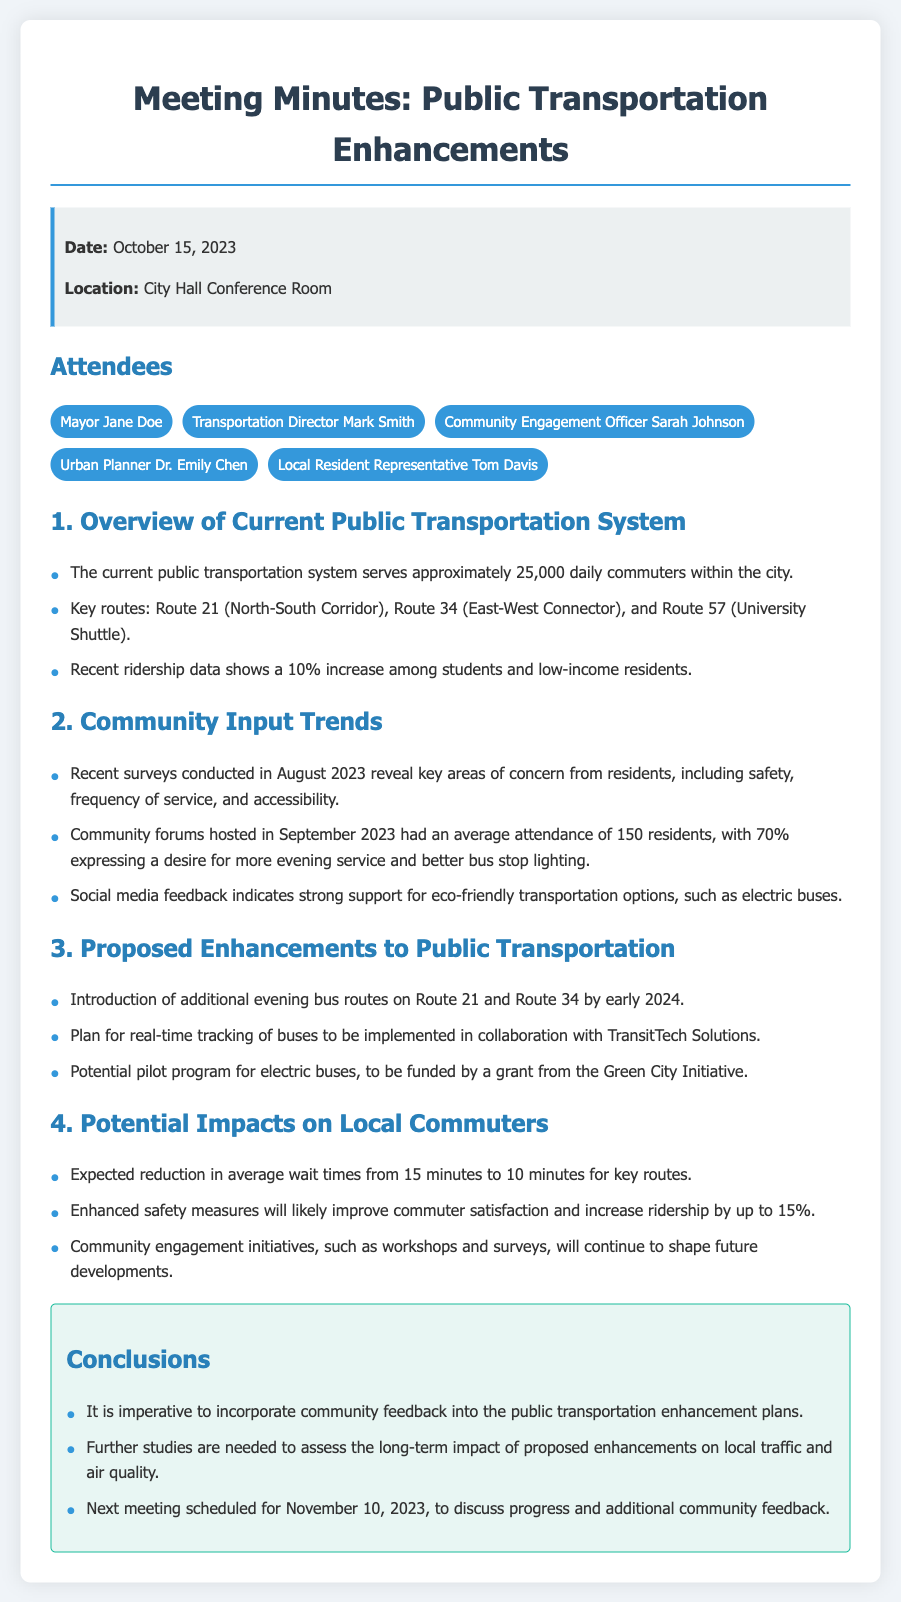What is the date of the meeting? The date of the meeting is stated in the info box at the top of the document.
Answer: October 15, 2023 Who is the Transportation Director? The document lists the attendees, including the Transportation Director.
Answer: Mark Smith What percentage of community forum attendees want more evening service? The survey results from community forums indicate the desires of attendees.
Answer: 70% What is the expected reduction in average wait times? The document specifies the expected improvement in average wait times for key routes.
Answer: From 15 minutes to 10 minutes What type of buses are included in the potential pilot program? The proposed enhancements section discusses various improvements, including bus types.
Answer: Electric buses What is the next meeting's scheduled date? The conclusion section mentions the date of the next meeting.
Answer: November 10, 2023 How many daily commuters does the current public transportation system serve? The overview of the current system indicates the number of daily commuters.
Answer: Approximately 25,000 What is a key area of concern from community surveys? The community input trends section highlights major concerns raised by residents.
Answer: Safety 